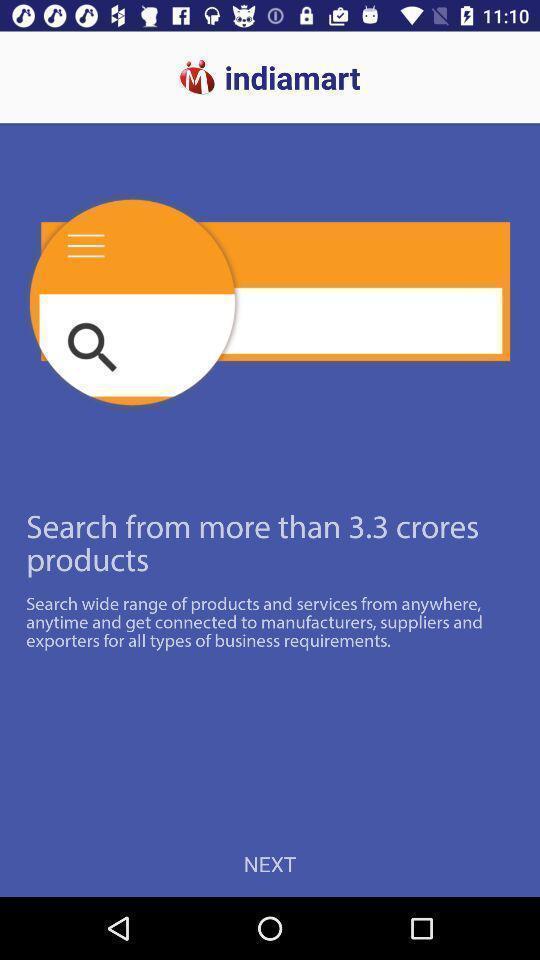Describe the content in this image. Welcome page for an online shopping application. 